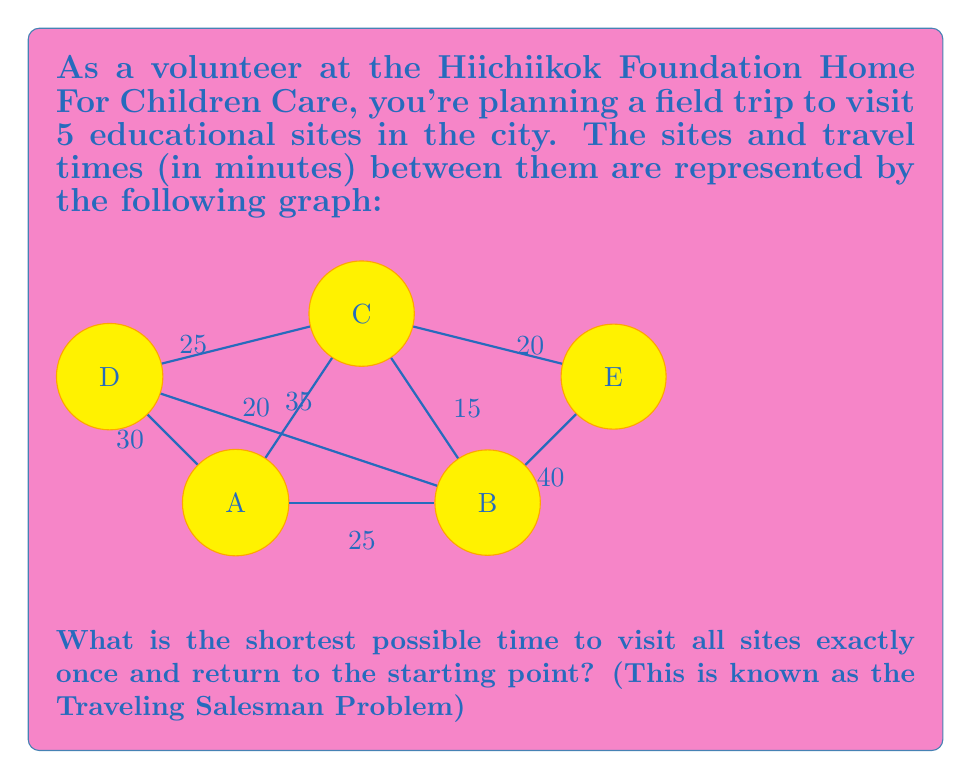What is the answer to this math problem? To solve this Traveling Salesman Problem, we need to find the shortest Hamiltonian cycle in the graph. Since there are 5 vertices, there are $(5-1)! = 24$ possible cycles to consider. Let's approach this step-by-step:

1) First, let's list all possible cycles (starting and ending at A):
   ABCDEA, ABCEDA, ABDCEA, ABDECA, ABEDCA, ABECDA,
   ACBDEA, ACBEDA, ACDEBA, ACEDBA, ADBCEA, ADBECA,
   ADCBEA, ADCEBA, ADEBCA, ADECBA, AEBCDA, AEBDCA,
   AECBDA, AECDBA, AEDBCA, AEDCBA

2) Now, we need to calculate the total time for each cycle. Let's do this for a few examples:

   ABCDEA: 25 + 15 + 25 + 35 + 40 = 140 minutes
   ACBDEA: 20 + 15 + 35 + 30 + 25 = 125 minutes
   ADBCEA: 30 + 35 + 15 + 20 + 25 = 125 minutes

3) After calculating all cycles, we find that the shortest time is 125 minutes, which can be achieved by multiple routes, including ACBDEA and ADBCEA.

4) To verify this is indeed the shortest path, we can use the following logic:
   - Any path must use at least 4 edges to visit all vertices.
   - The sum of the 4 smallest edges is 15 + 20 + 20 + 25 = 80.
   - To complete the cycle, we need one more edge, which must be at least 35 (as all remaining edges are 35 or larger).
   - This gives a lower bound of 115 minutes, which our solution exceeds by only 10 minutes.

Therefore, the shortest possible time to visit all sites once and return to the starting point is 125 minutes.
Answer: 125 minutes 